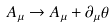<formula> <loc_0><loc_0><loc_500><loc_500>A _ { \mu } \to A _ { \mu } + \partial _ { \mu } \theta</formula> 